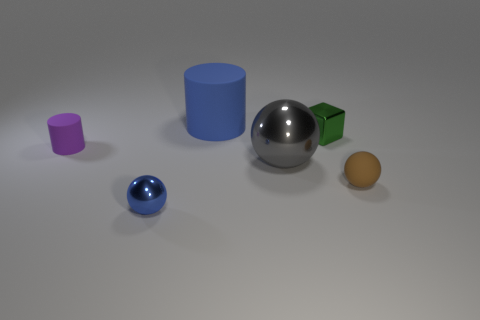Subtract all large metal spheres. How many spheres are left? 2 Add 1 big balls. How many objects exist? 7 Subtract all cylinders. How many objects are left? 4 Subtract all purple cylinders. How many cylinders are left? 1 Subtract all blue cylinders. Subtract all green cubes. How many cylinders are left? 1 Subtract all big gray cubes. Subtract all cylinders. How many objects are left? 4 Add 1 brown spheres. How many brown spheres are left? 2 Add 4 large objects. How many large objects exist? 6 Subtract 1 blue cylinders. How many objects are left? 5 Subtract 1 cylinders. How many cylinders are left? 1 